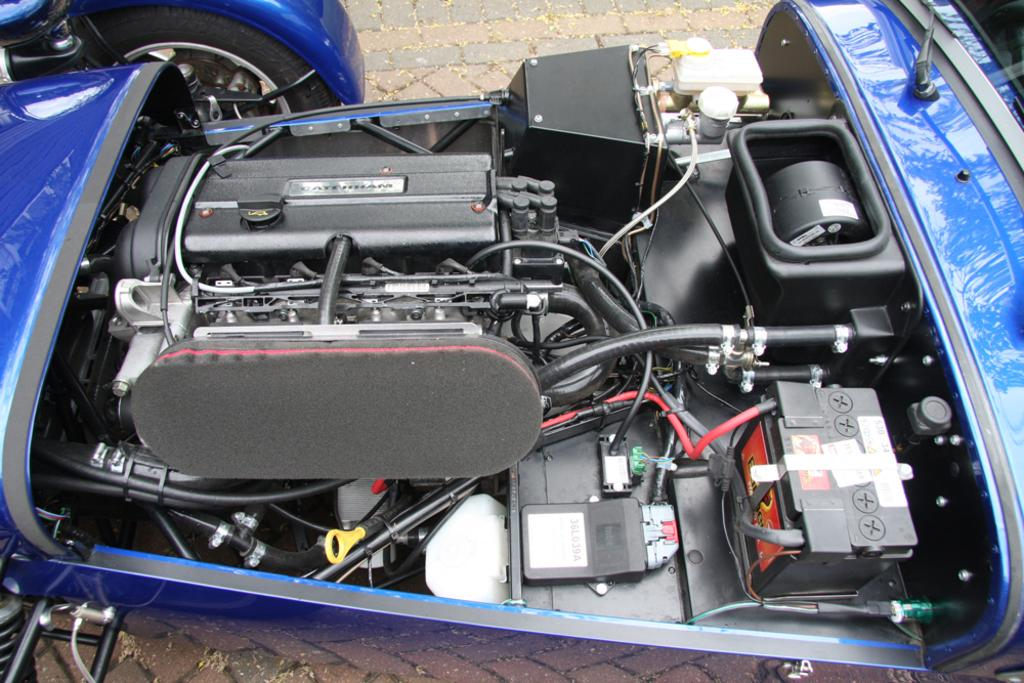What color is the car in the image? The car in the image is blue. Where is the car located in the image? The car is parked on the road. What part of the car can be seen in the image? The engine of the car is visible. How many wheels can be seen in the image? There is one wheel visible in the image. Can you describe the sense of humor of the man in the image? There is no man present in the image, so it is not possible to describe his sense of humor. 